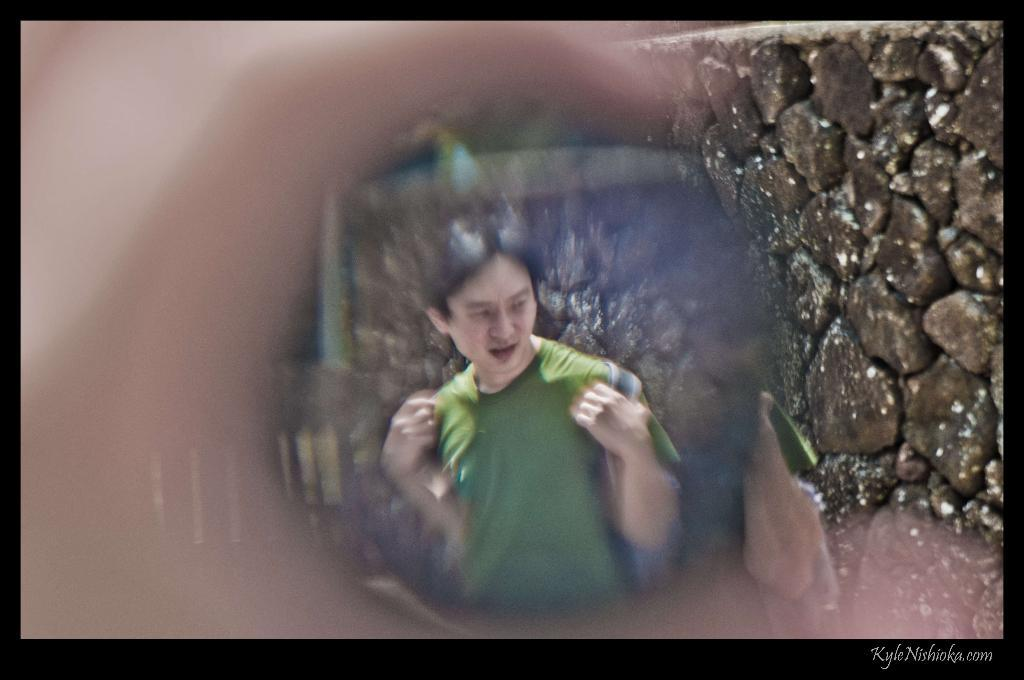What is the main subject of the image? There is a person in the image. What is the person wearing? The person is wearing a green t-shirt. What is the person holding? The person is holding a bag. What type of background can be seen in the image? There is a rock wall in the image. What type of pear is hanging from the rock wall in the image? There is no pear present in the image; it features a person wearing a green t-shirt, holding a bag, and standing in front of a rock wall. What type of beam is supporting the rock wall in the image? The image does not show any beams supporting the rock wall; it only shows the rock wall as the background. 